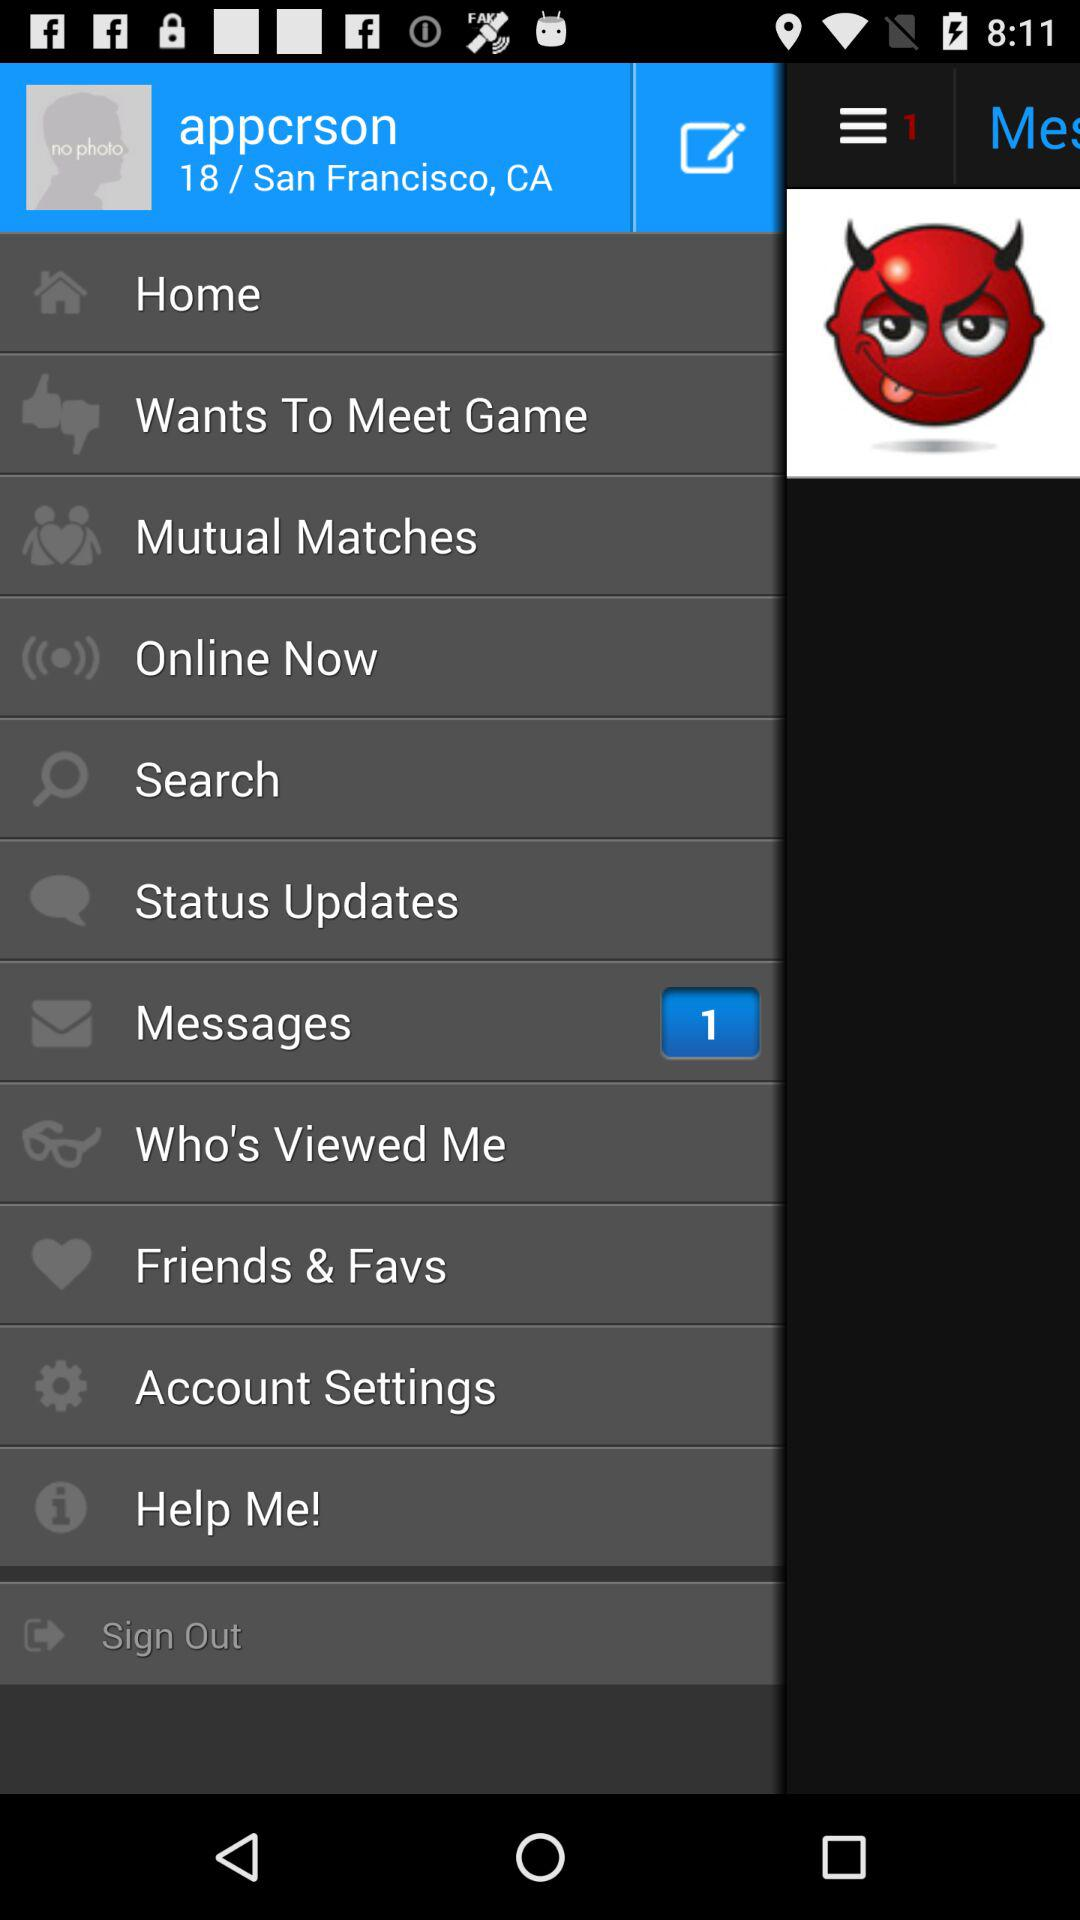What is the location? The location is San Francisco, CA. 